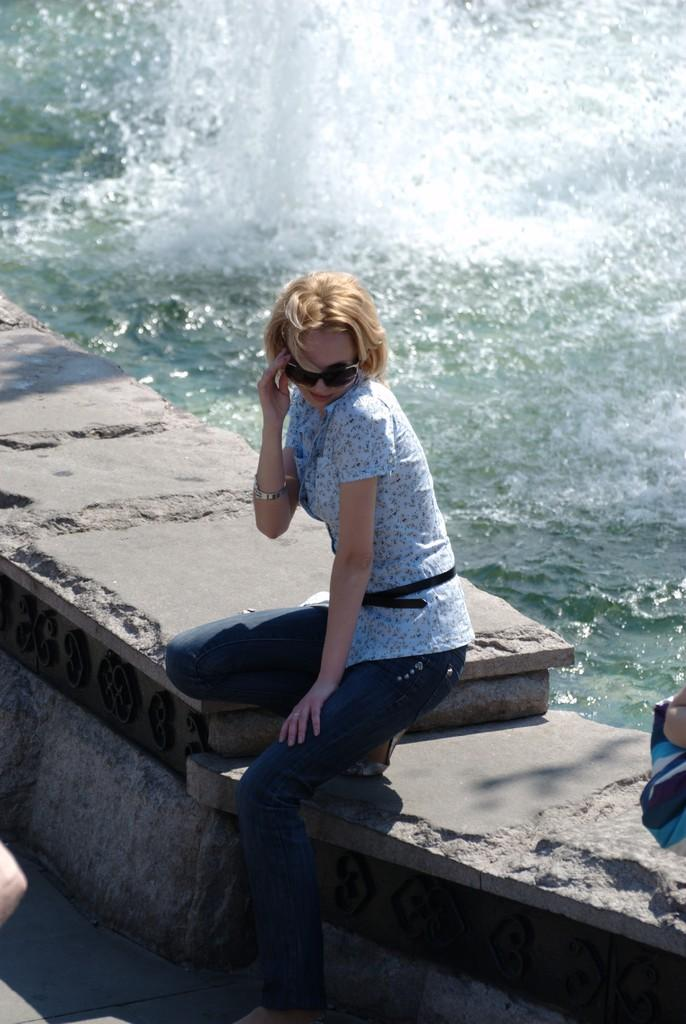Who is the main subject in the image? There is a lady in the center of the image. What is the lady doing in the image? The lady is sitting on a wall. What is the lady wearing that is related to her activity? The lady is wearing goggles. What can be seen at the top of the image? There is water visible at the top of the image. What can be seen at the bottom of the image? There is ground visible at the bottom of the image. What is the purpose of the lady crying in the image? There is no indication in the image that the lady is crying; she is wearing goggles and sitting on a wall. 